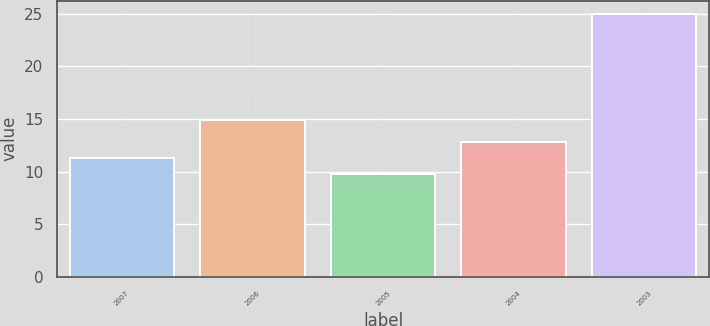Convert chart to OTSL. <chart><loc_0><loc_0><loc_500><loc_500><bar_chart><fcel>2007<fcel>2006<fcel>2005<fcel>2004<fcel>2003<nl><fcel>11.32<fcel>14.9<fcel>9.8<fcel>12.84<fcel>25<nl></chart> 